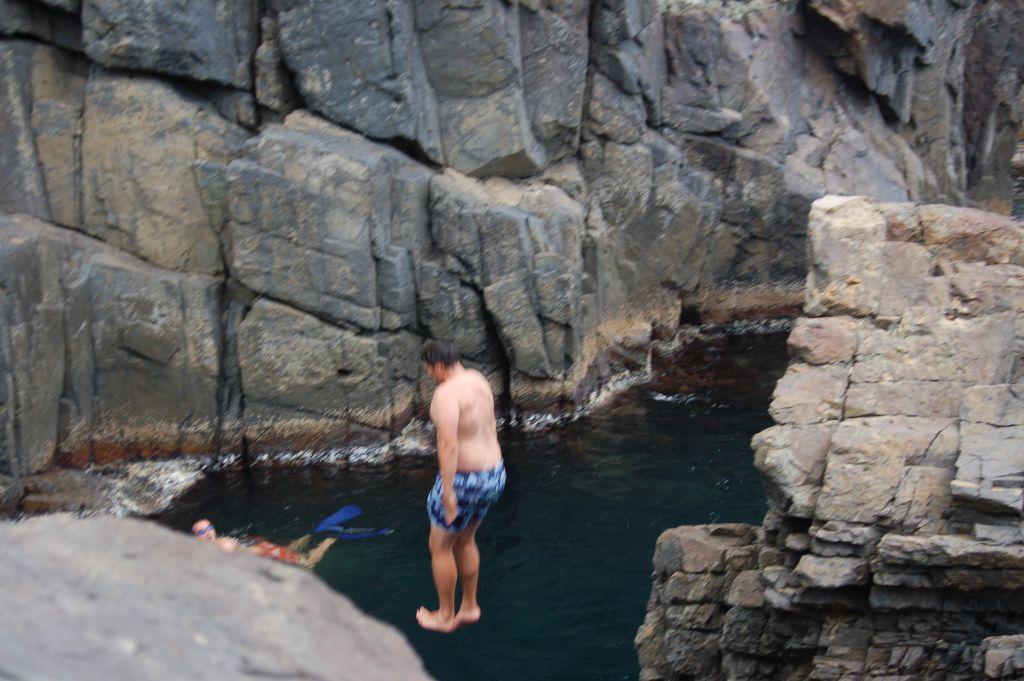Could you give a brief overview of what you see in this image? In the middle of the image there is a man with blue short is jumping into the water. And in the water there is a person. At the left bottom of the image there is a rock. And at the right side of the image there are rocks. And in the background there are rocks. 